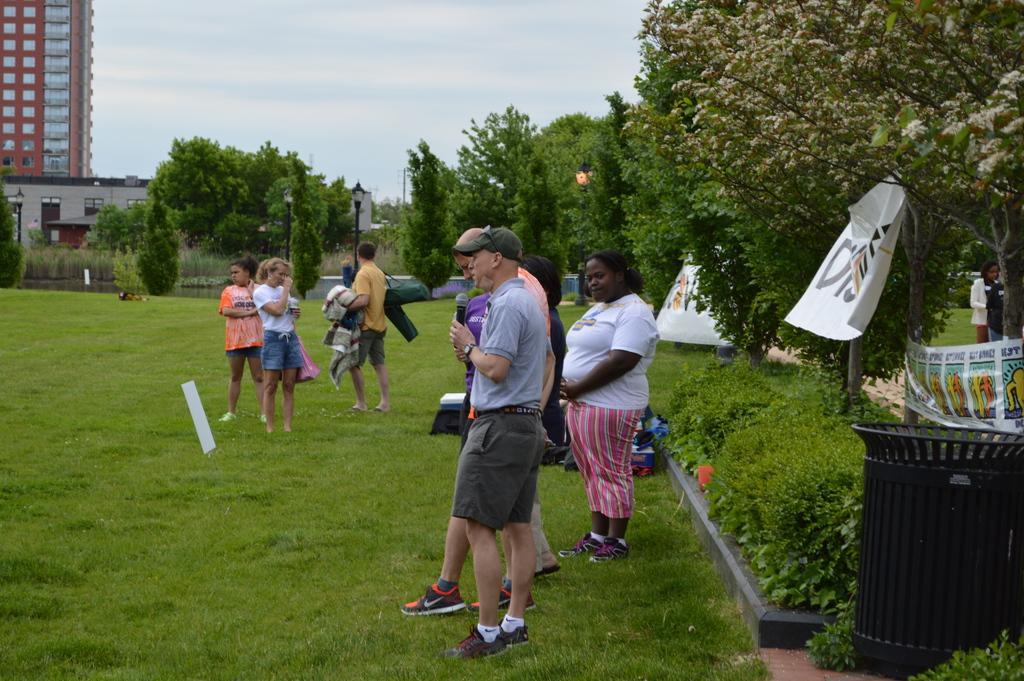Please provide a concise description of this image. This picture is clicked outside the city. Here, we see many people standing in the garden. The man in blue T-shirt is holding a microphone in his hand and he is talking on the microphone. The man in yellow T-shirt is holding something in his hand. At the bottom of the picture, we see grass. There are trees, street lights and buildings in the background. In the right bottom of the picture, we see garbage bin and white color banners. At the top of the picture, we see the sky. 